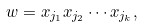Convert formula to latex. <formula><loc_0><loc_0><loc_500><loc_500>w = x _ { j _ { 1 } } x _ { j _ { 2 } } \cdots x _ { j _ { k } } ,</formula> 